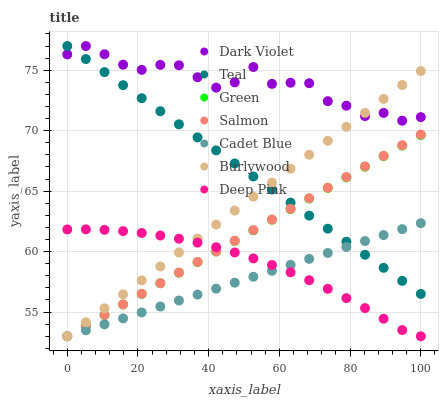Does Cadet Blue have the minimum area under the curve?
Answer yes or no. Yes. Does Dark Violet have the maximum area under the curve?
Answer yes or no. Yes. Does Burlywood have the minimum area under the curve?
Answer yes or no. No. Does Burlywood have the maximum area under the curve?
Answer yes or no. No. Is Green the smoothest?
Answer yes or no. Yes. Is Dark Violet the roughest?
Answer yes or no. Yes. Is Burlywood the smoothest?
Answer yes or no. No. Is Burlywood the roughest?
Answer yes or no. No. Does Cadet Blue have the lowest value?
Answer yes or no. Yes. Does Dark Violet have the lowest value?
Answer yes or no. No. Does Teal have the highest value?
Answer yes or no. Yes. Does Burlywood have the highest value?
Answer yes or no. No. Is Salmon less than Dark Violet?
Answer yes or no. Yes. Is Dark Violet greater than Cadet Blue?
Answer yes or no. Yes. Does Burlywood intersect Salmon?
Answer yes or no. Yes. Is Burlywood less than Salmon?
Answer yes or no. No. Is Burlywood greater than Salmon?
Answer yes or no. No. Does Salmon intersect Dark Violet?
Answer yes or no. No. 